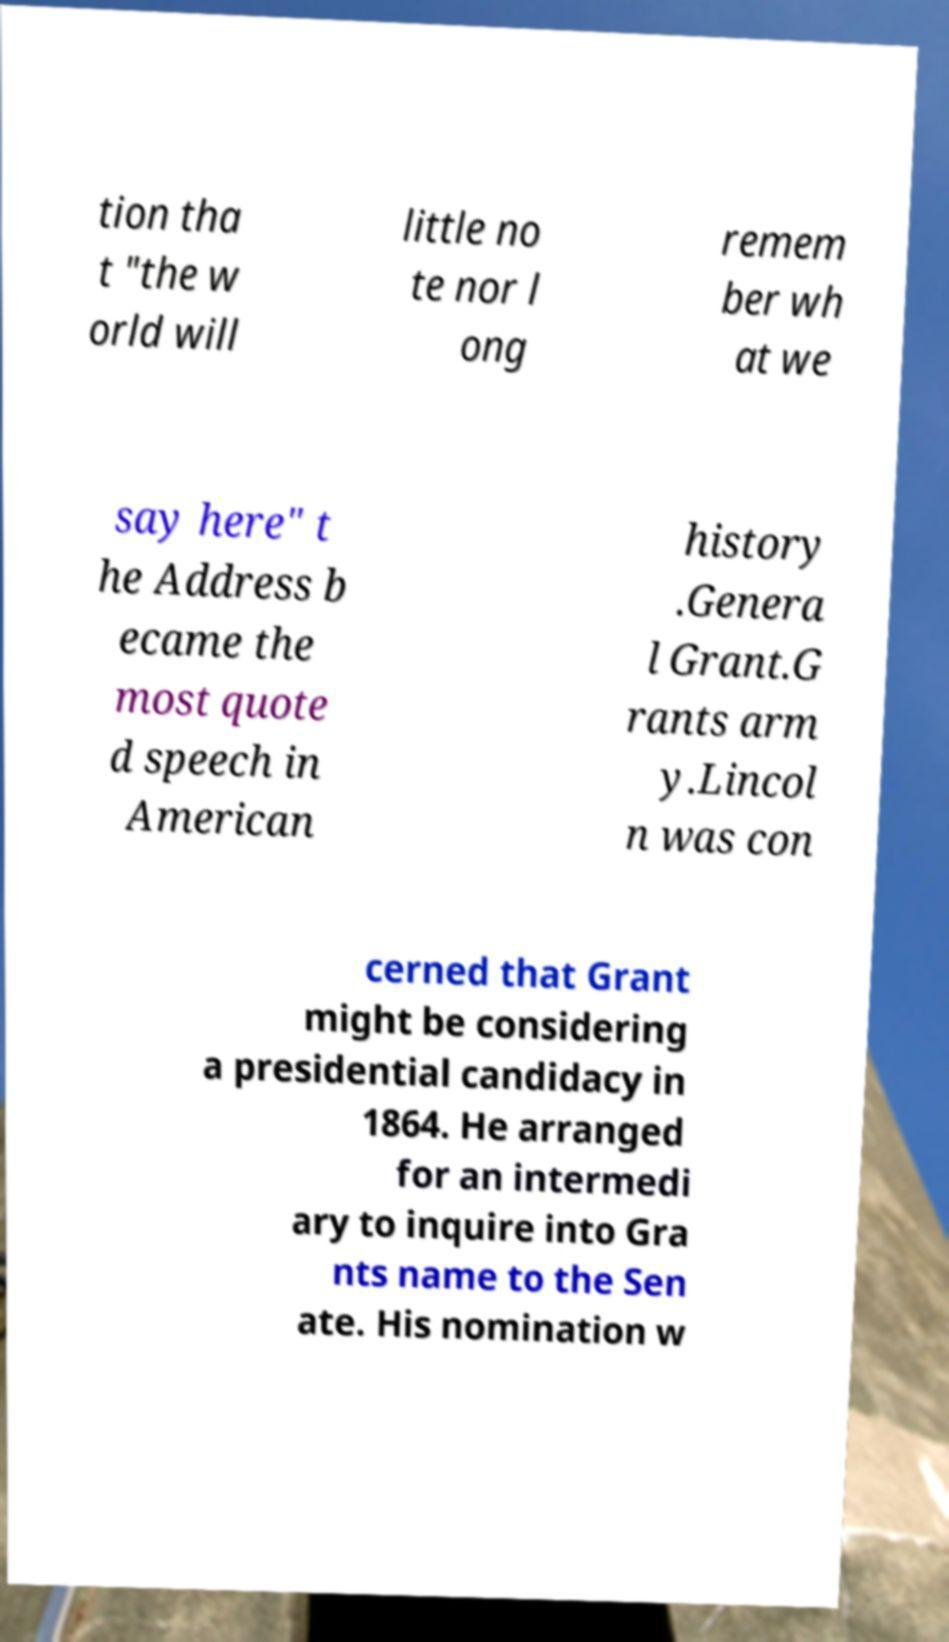Can you accurately transcribe the text from the provided image for me? tion tha t "the w orld will little no te nor l ong remem ber wh at we say here" t he Address b ecame the most quote d speech in American history .Genera l Grant.G rants arm y.Lincol n was con cerned that Grant might be considering a presidential candidacy in 1864. He arranged for an intermedi ary to inquire into Gra nts name to the Sen ate. His nomination w 